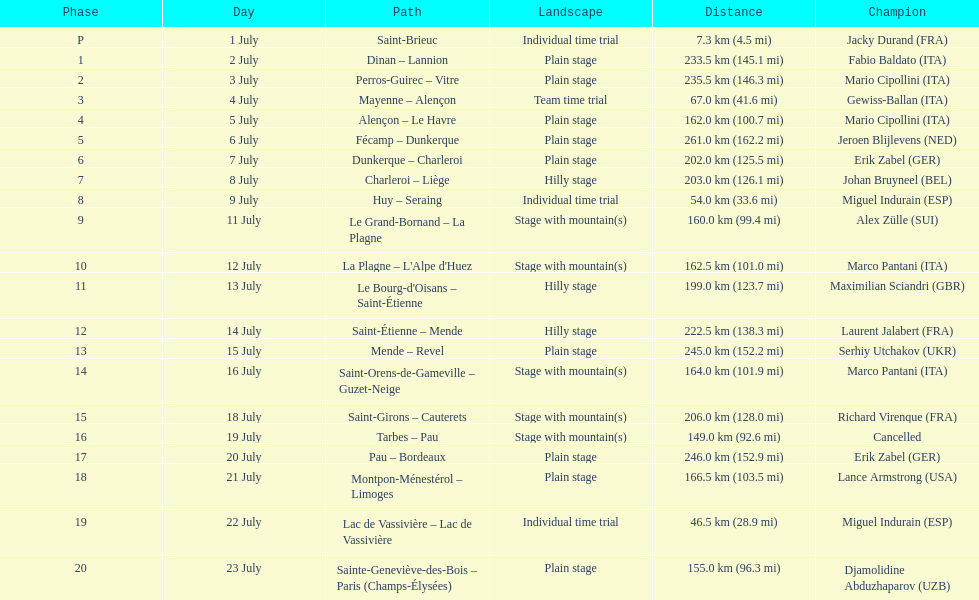After lance armstrong, who led next in the 1995 tour de france? Miguel Indurain. 